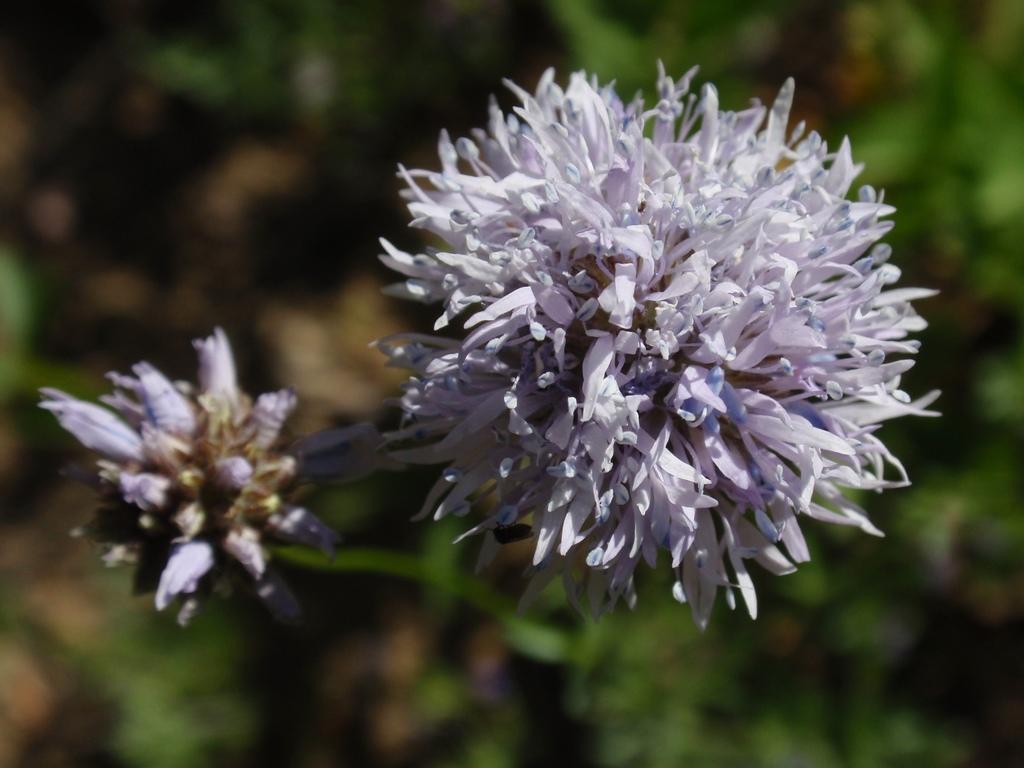Can you describe this image briefly? This image consists of a flower in white and blue color. In the background, there are plants. And the background, is blurred. 